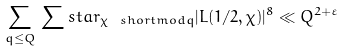Convert formula to latex. <formula><loc_0><loc_0><loc_500><loc_500>\sum _ { q \leq Q } \, \sum s t a r _ { \chi \ s h o r t m o d { q } } | L ( 1 / 2 , \chi ) | ^ { 8 } \ll Q ^ { 2 + \varepsilon }</formula> 